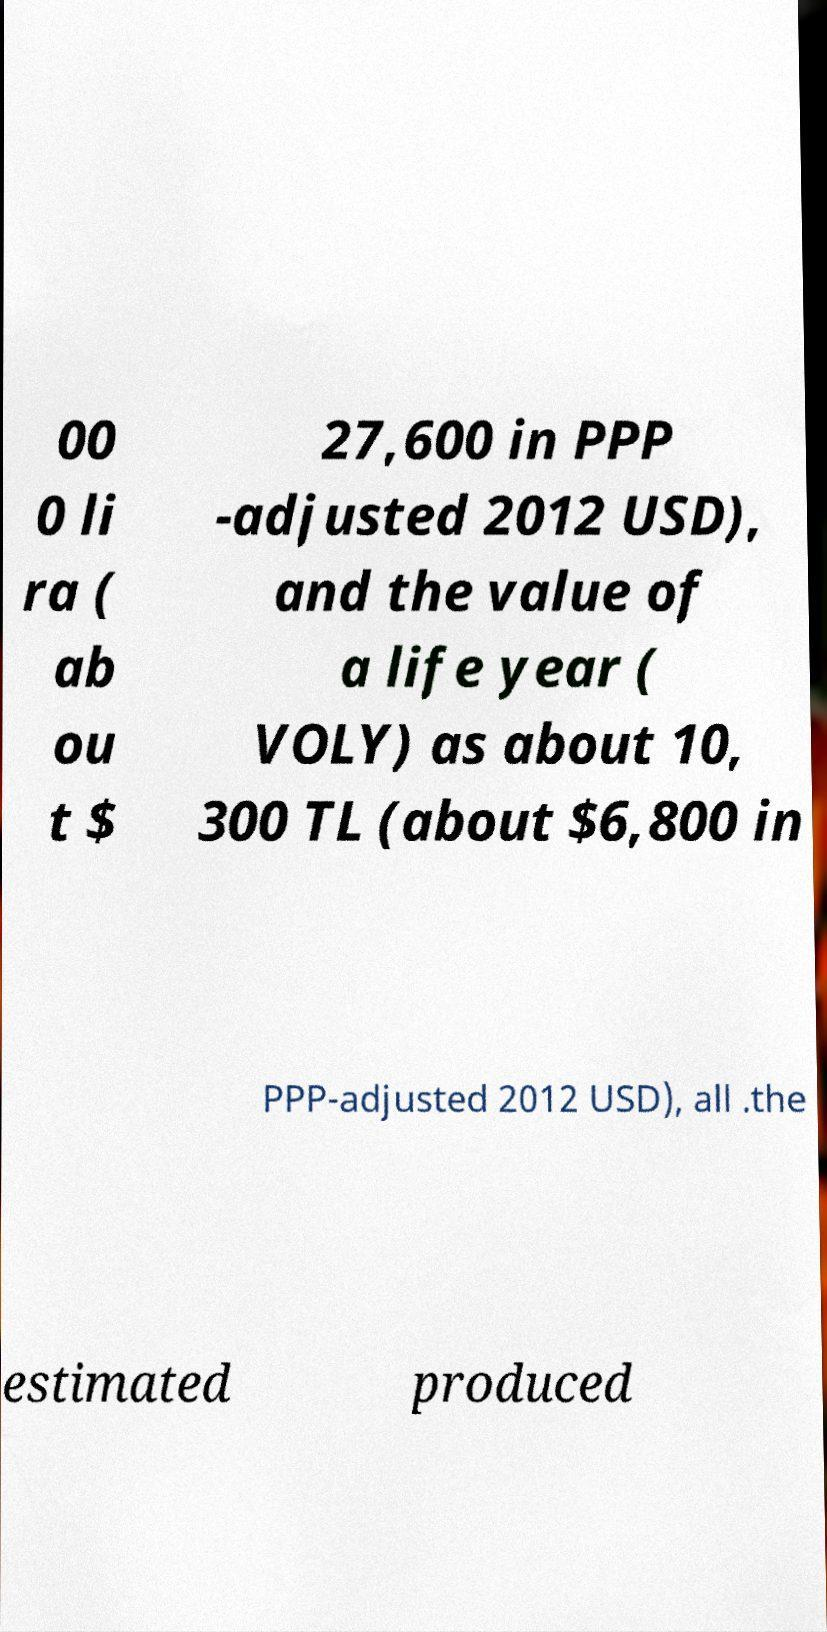Can you read and provide the text displayed in the image?This photo seems to have some interesting text. Can you extract and type it out for me? 00 0 li ra ( ab ou t $ 27,600 in PPP -adjusted 2012 USD), and the value of a life year ( VOLY) as about 10, 300 TL (about $6,800 in PPP-adjusted 2012 USD), all .the estimated produced 